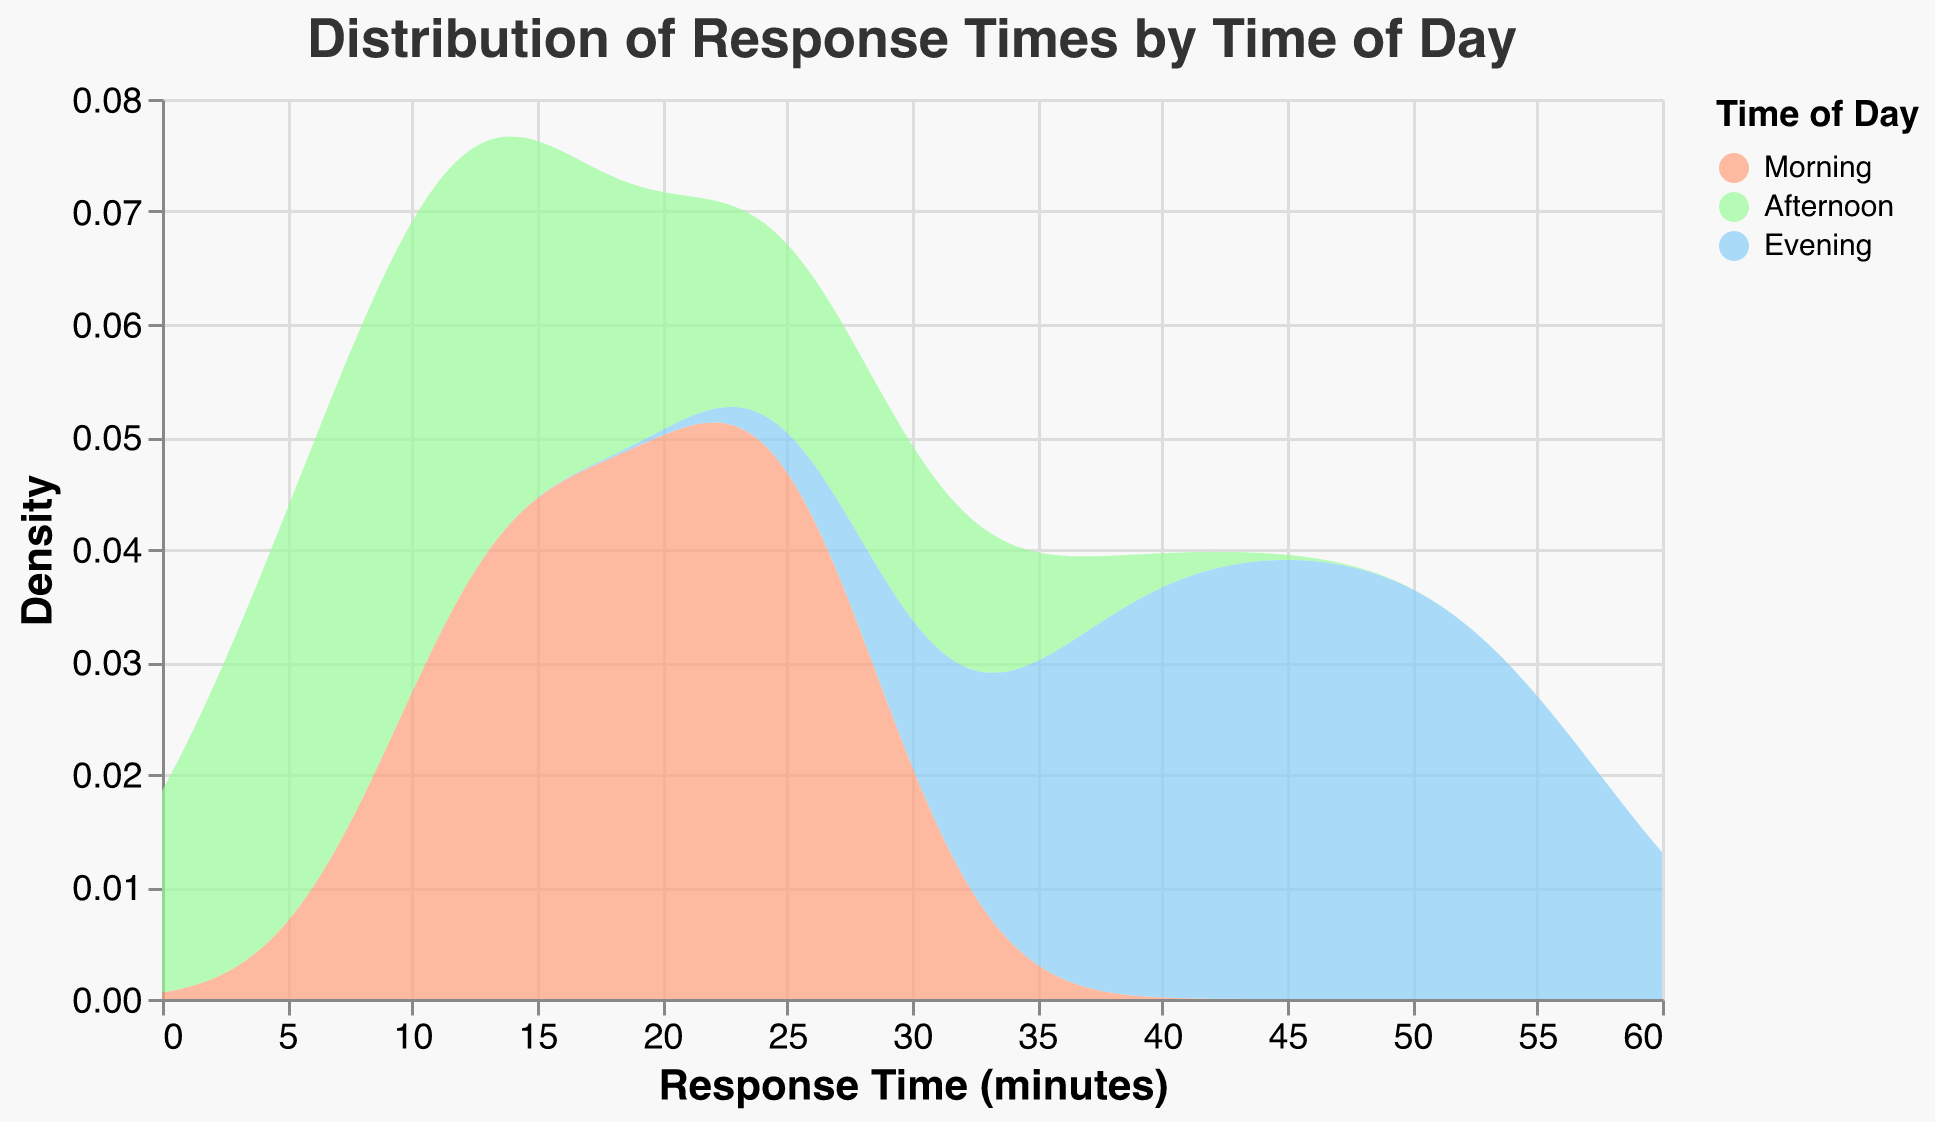What is the title of the figure? The title is placed at the top of the figure and it states the main topic being visualized.
Answer: Distribution of Response Times by Time of Day What are the axis labels in the figure? The labels on the horizontal and vertical axes denote what each axis represents.
Answer: Response Time (minutes) and Density What colors are used to represent the different times of day? The figure uses distinct colors to differentiate between the times of day. You can see a legend explaining the colors.
Answer: Morning (#FFA07A), Afternoon (#98FB98), Evening (#87CEFA) Which time of day has the highest peak in density for response times? Identify the highest point in the density curves for each time of day and compare them.
Answer: Evening Which time of day shows the shortest response times? Look at the distribution of response times and find which time of day has values starting from the smallest response time.
Answer: Afternoon Compare the response time distribution between Morning and Afternoon. Which has a wider spread? Examine the range of response times for both times of day and identify which has a broader distribution.
Answer: Morning During what time of day are response times predominantly 15-25 minutes? Check the density curves to see which time of day has the most density around the 15-25 minute range.
Answer: Morning Which time of day has the most consistent (least spread out) response times? Look for the time of day with the narrowest density range, indicating more consistent response times.
Answer: Afternoon What is the average response time during the Evening? The Evening density curve peaks and spreads more towards the higher response times. Estimating the average requires integrating the area under the curve. It's beyond a visual inspection, but a midpoint estimation suggests higher response times.
Answer: Approximately 45 minutes 